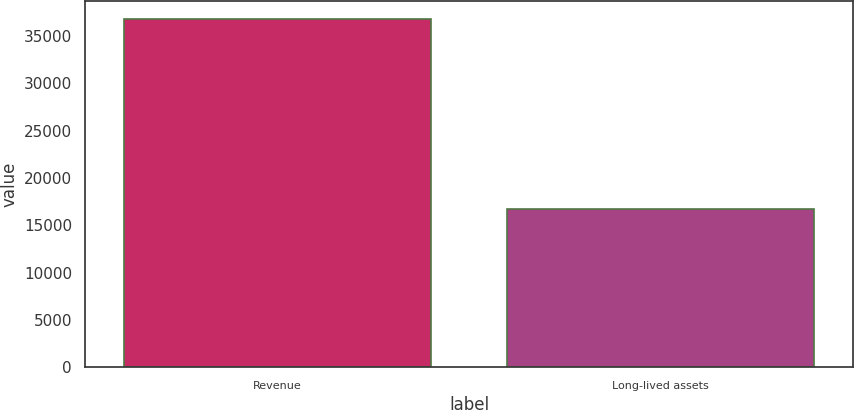Convert chart to OTSL. <chart><loc_0><loc_0><loc_500><loc_500><bar_chart><fcel>Revenue<fcel>Long-lived assets<nl><fcel>36795<fcel>16693<nl></chart> 